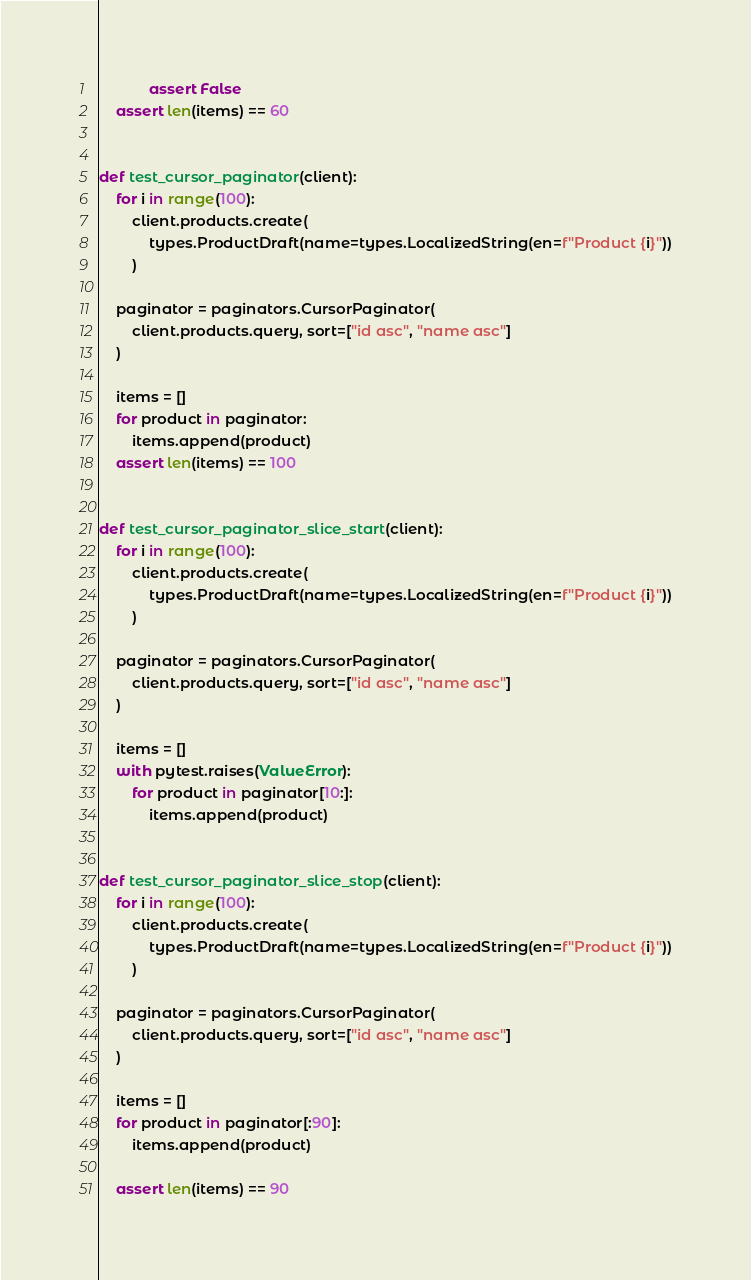<code> <loc_0><loc_0><loc_500><loc_500><_Python_>            assert False
    assert len(items) == 60


def test_cursor_paginator(client):
    for i in range(100):
        client.products.create(
            types.ProductDraft(name=types.LocalizedString(en=f"Product {i}"))
        )

    paginator = paginators.CursorPaginator(
        client.products.query, sort=["id asc", "name asc"]
    )

    items = []
    for product in paginator:
        items.append(product)
    assert len(items) == 100


def test_cursor_paginator_slice_start(client):
    for i in range(100):
        client.products.create(
            types.ProductDraft(name=types.LocalizedString(en=f"Product {i}"))
        )

    paginator = paginators.CursorPaginator(
        client.products.query, sort=["id asc", "name asc"]
    )

    items = []
    with pytest.raises(ValueError):
        for product in paginator[10:]:
            items.append(product)


def test_cursor_paginator_slice_stop(client):
    for i in range(100):
        client.products.create(
            types.ProductDraft(name=types.LocalizedString(en=f"Product {i}"))
        )

    paginator = paginators.CursorPaginator(
        client.products.query, sort=["id asc", "name asc"]
    )

    items = []
    for product in paginator[:90]:
        items.append(product)

    assert len(items) == 90
</code> 